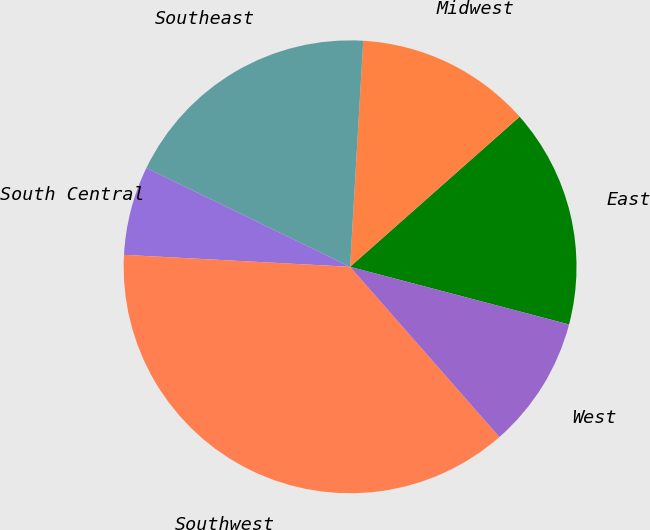<chart> <loc_0><loc_0><loc_500><loc_500><pie_chart><fcel>East<fcel>Midwest<fcel>Southeast<fcel>South Central<fcel>Southwest<fcel>West<nl><fcel>15.63%<fcel>12.54%<fcel>18.73%<fcel>6.35%<fcel>37.3%<fcel>9.44%<nl></chart> 